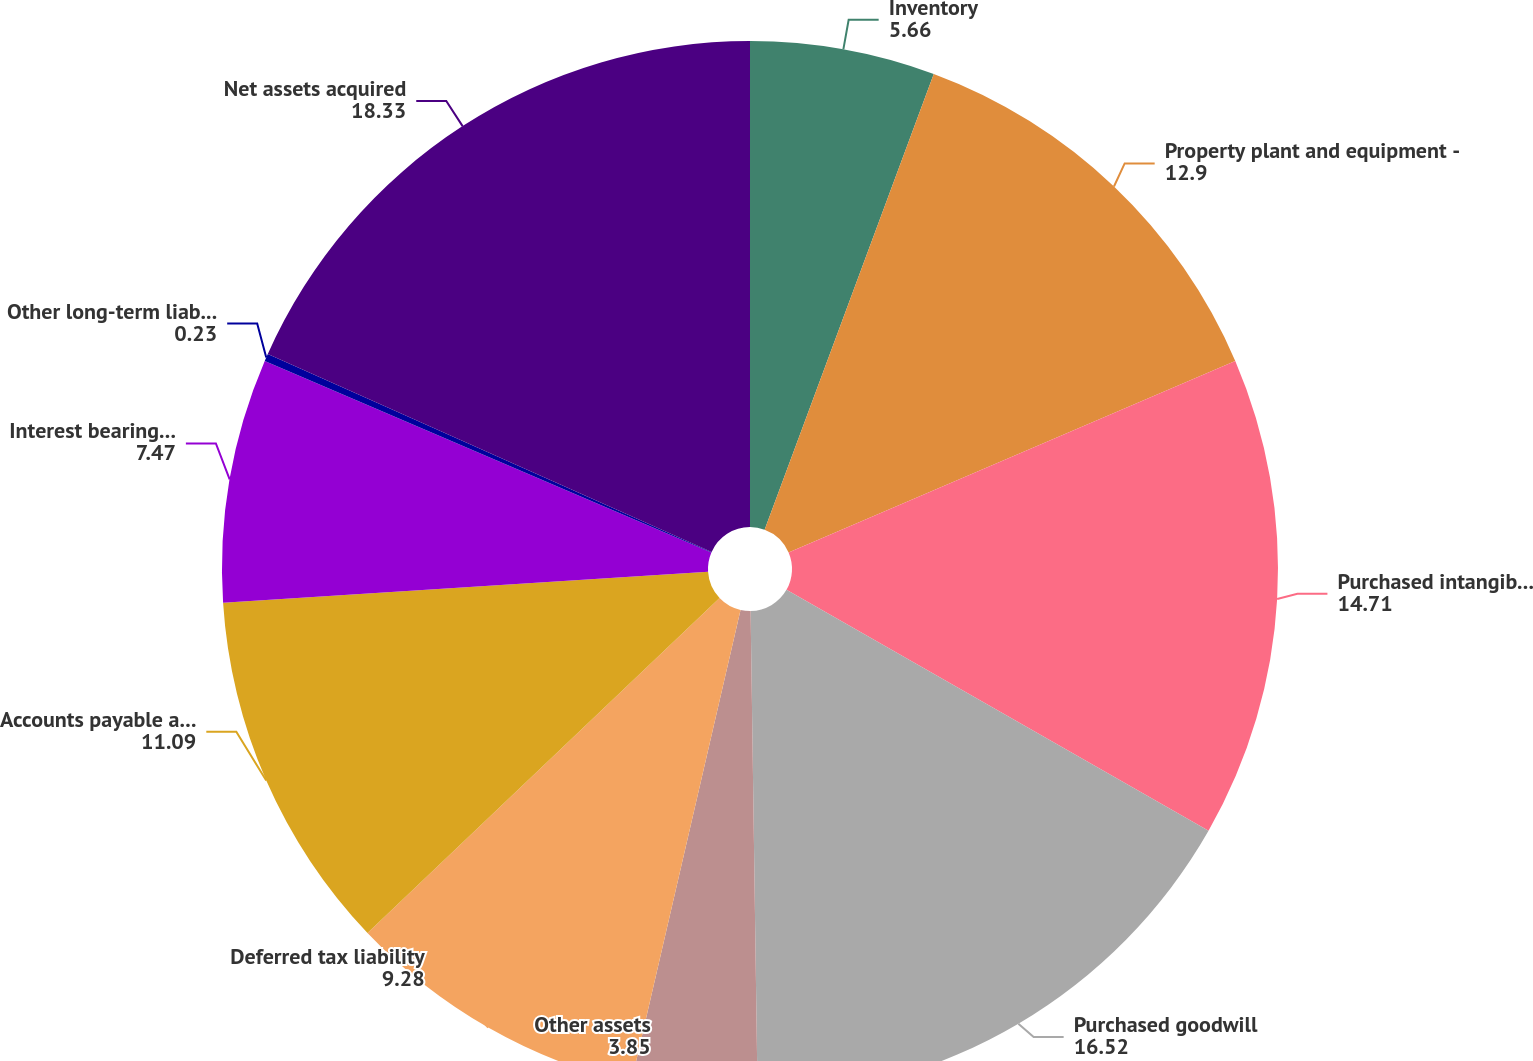Convert chart. <chart><loc_0><loc_0><loc_500><loc_500><pie_chart><fcel>Inventory<fcel>Property plant and equipment -<fcel>Purchased intangible assets<fcel>Purchased goodwill<fcel>Other assets<fcel>Deferred tax liability<fcel>Accounts payable and other<fcel>Interest bearing debt<fcel>Other long-term liabilities<fcel>Net assets acquired<nl><fcel>5.66%<fcel>12.9%<fcel>14.71%<fcel>16.52%<fcel>3.85%<fcel>9.28%<fcel>11.09%<fcel>7.47%<fcel>0.23%<fcel>18.33%<nl></chart> 